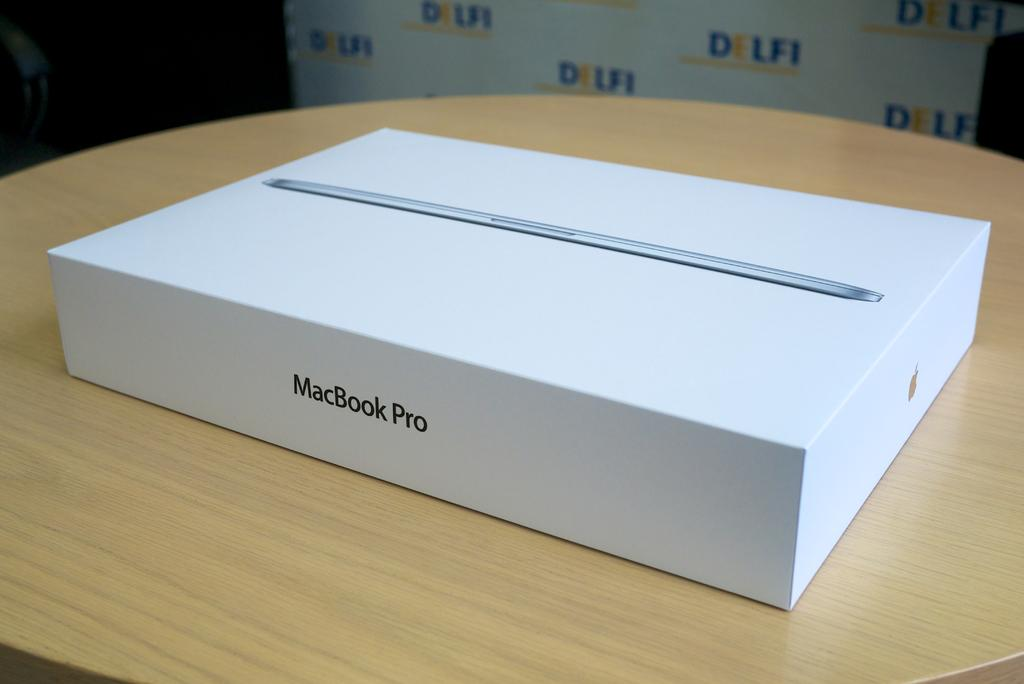<image>
Relay a brief, clear account of the picture shown. A box of MacBook Pro placed on a round table. 